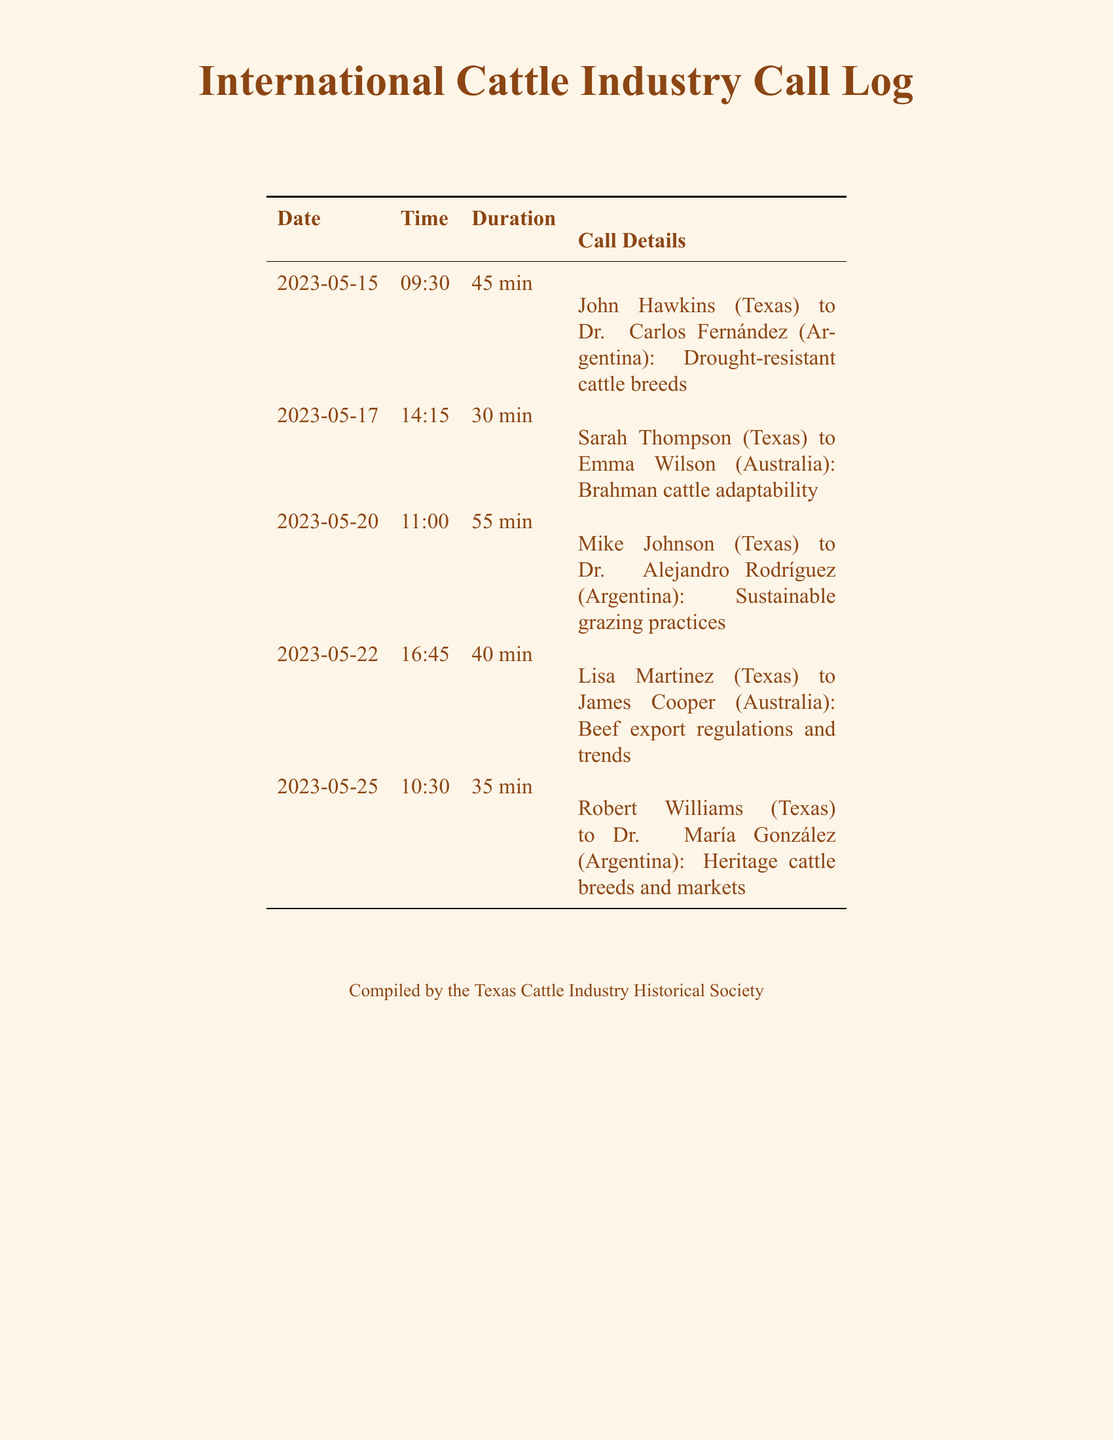What is the duration of the call on May 20th? The duration of the call on May 20th is found in the "Duration" column for that date, which is 55 min.
Answer: 55 min Who did Lisa Martinez speak with on May 22nd? The call details section indicates that Lisa Martinez spoke with James Cooper on May 22nd.
Answer: James Cooper What is the main topic of the call between John Hawkins and Dr. Carlos Fernández? The topic is specified in the call details, mentioning drought-resistant cattle breeds as the main focus.
Answer: Drought-resistant cattle breeds How many calls were made to experts in Argentina? By counting the entries for calls made to Dr. Carlos Fernández and Dr. María González, there are a total of two calls made to experts in Argentina.
Answer: 2 What time was Mike Johnson’s call to Dr. Alejandro Rodríguez? The time is listed in the call details for Mike Johnson's call, which is 11:00.
Answer: 11:00 What is a common theme among the calls made to Australia? The call topics to Australia generally focus on adaptability and regulations within the beef industry, suggesting a common theme of industry practices.
Answer: Industry practices How long was the call on May 25th? The duration of the call on May 25th is 35 min, indicated in the "Duration" column.
Answer: 35 min Who is the compiler of the call log? The compiler is mentioned in the footnote at the bottom of the document, which states the Texas Cattle Industry Historical Society.
Answer: Texas Cattle Industry Historical Society 